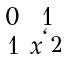Convert formula to latex. <formula><loc_0><loc_0><loc_500><loc_500>\begin{smallmatrix} 0 & 1 \\ 1 & x ^ { \ell _ { 2 } } \end{smallmatrix}</formula> 